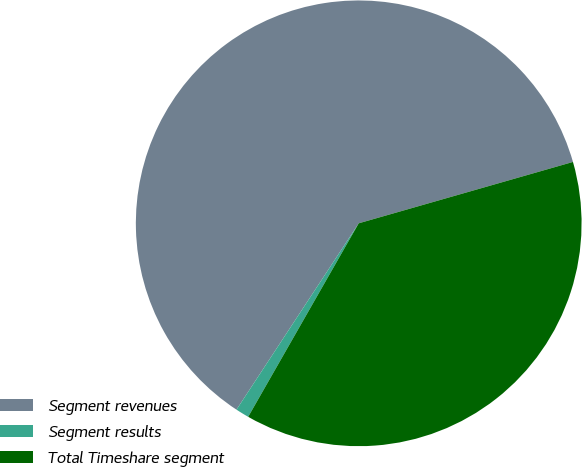Convert chart. <chart><loc_0><loc_0><loc_500><loc_500><pie_chart><fcel>Segment revenues<fcel>Segment results<fcel>Total Timeshare segment<nl><fcel>61.32%<fcel>0.98%<fcel>37.7%<nl></chart> 